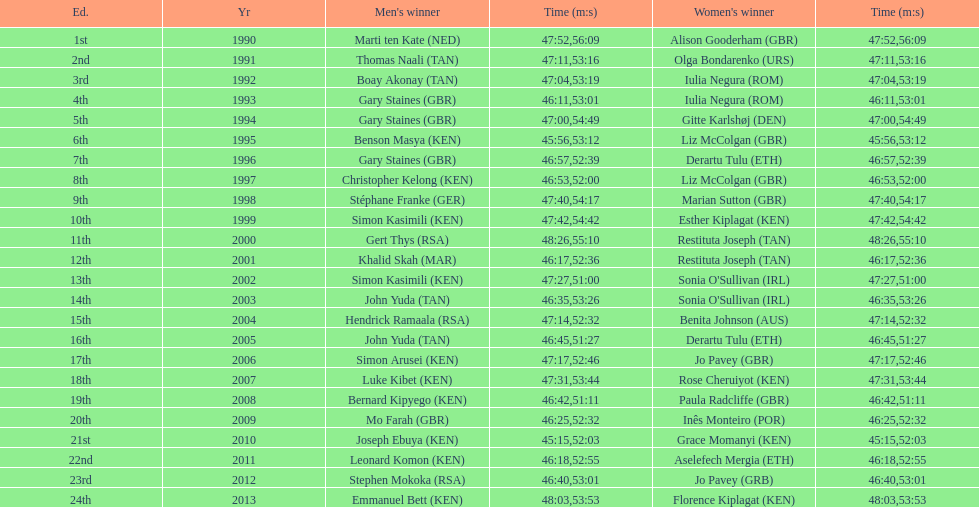Who has the fastest recorded finish for the men's bupa great south run, between 1990 and 2013? Joseph Ebuya (KEN). 